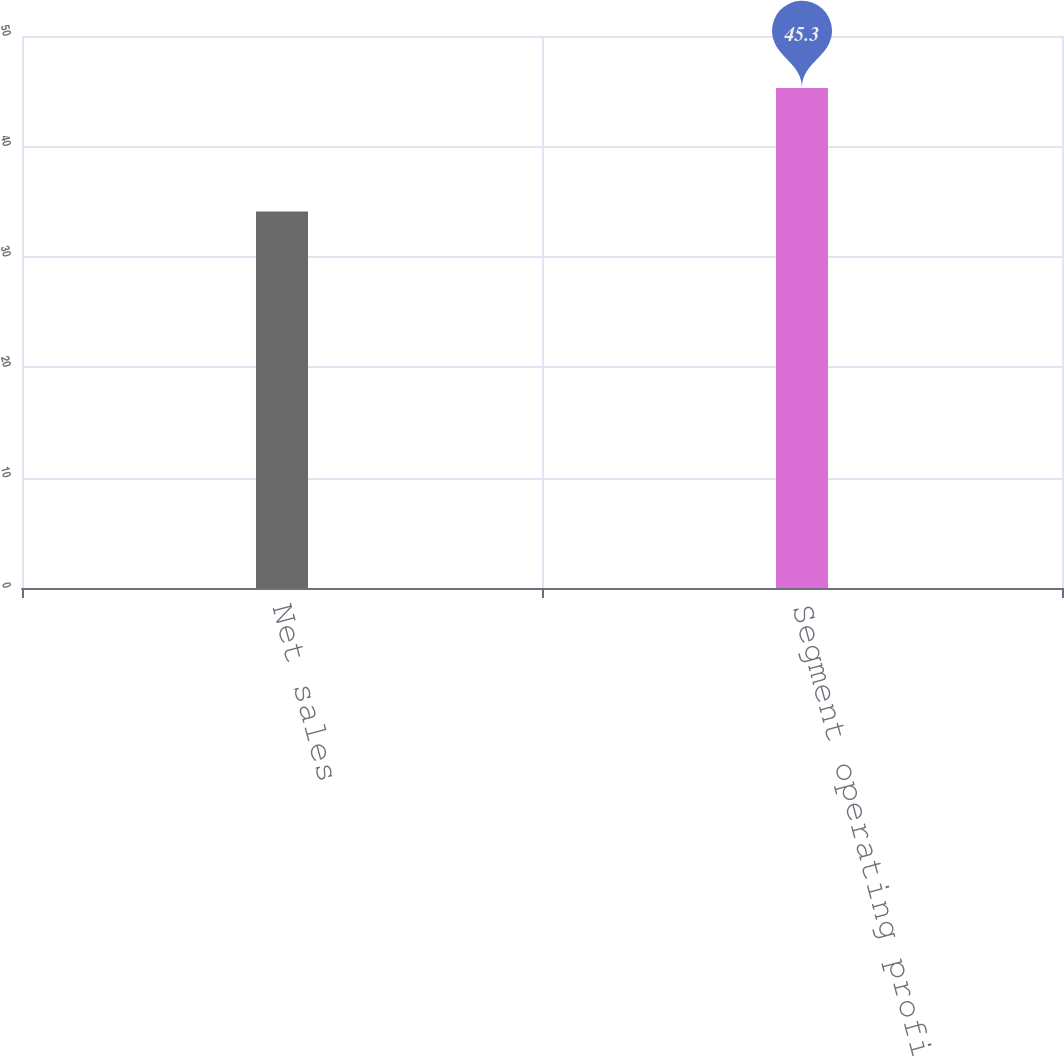Convert chart. <chart><loc_0><loc_0><loc_500><loc_500><bar_chart><fcel>Net sales<fcel>Segment operating profit<nl><fcel>34.1<fcel>45.3<nl></chart> 